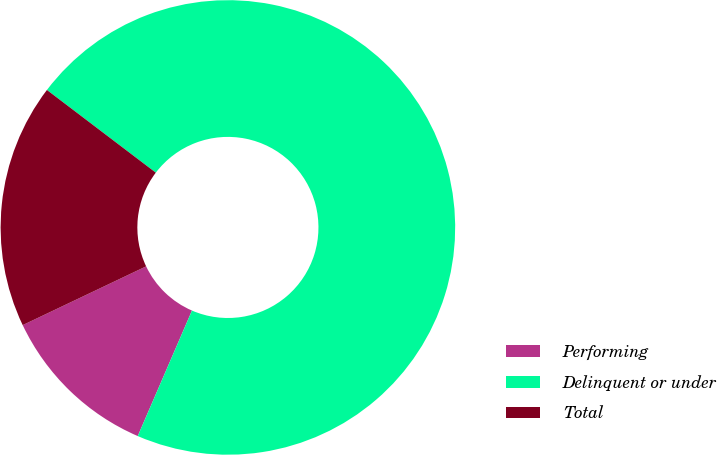<chart> <loc_0><loc_0><loc_500><loc_500><pie_chart><fcel>Performing<fcel>Delinquent or under<fcel>Total<nl><fcel>11.44%<fcel>71.16%<fcel>17.41%<nl></chart> 